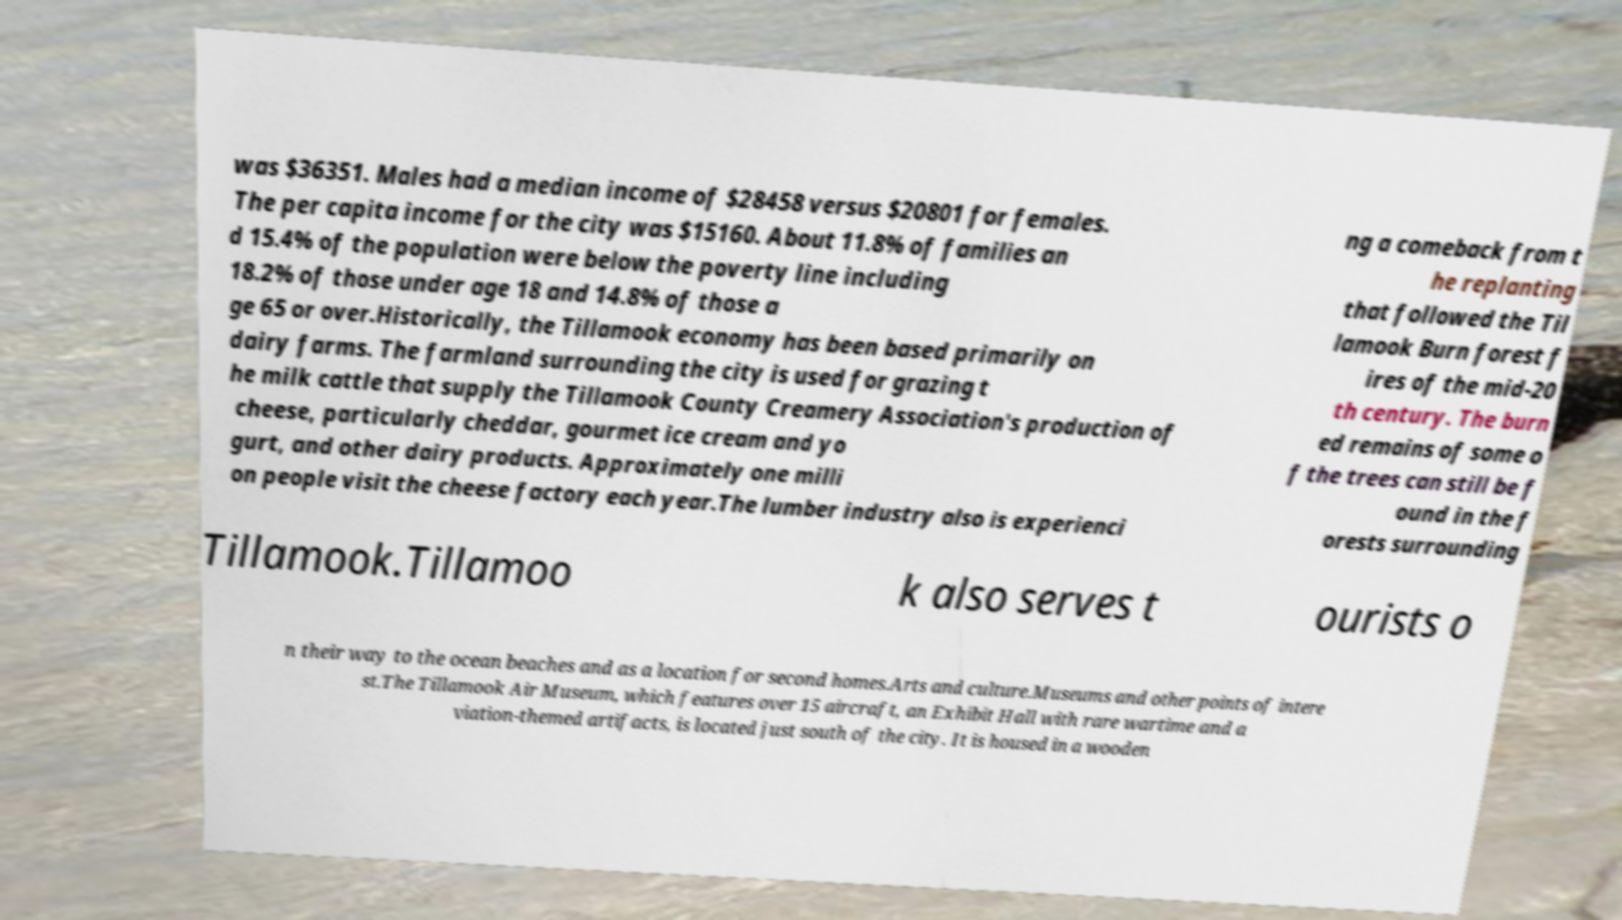Could you extract and type out the text from this image? was $36351. Males had a median income of $28458 versus $20801 for females. The per capita income for the city was $15160. About 11.8% of families an d 15.4% of the population were below the poverty line including 18.2% of those under age 18 and 14.8% of those a ge 65 or over.Historically, the Tillamook economy has been based primarily on dairy farms. The farmland surrounding the city is used for grazing t he milk cattle that supply the Tillamook County Creamery Association's production of cheese, particularly cheddar, gourmet ice cream and yo gurt, and other dairy products. Approximately one milli on people visit the cheese factory each year.The lumber industry also is experienci ng a comeback from t he replanting that followed the Til lamook Burn forest f ires of the mid-20 th century. The burn ed remains of some o f the trees can still be f ound in the f orests surrounding Tillamook.Tillamoo k also serves t ourists o n their way to the ocean beaches and as a location for second homes.Arts and culture.Museums and other points of intere st.The Tillamook Air Museum, which features over 15 aircraft, an Exhibit Hall with rare wartime and a viation-themed artifacts, is located just south of the city. It is housed in a wooden 